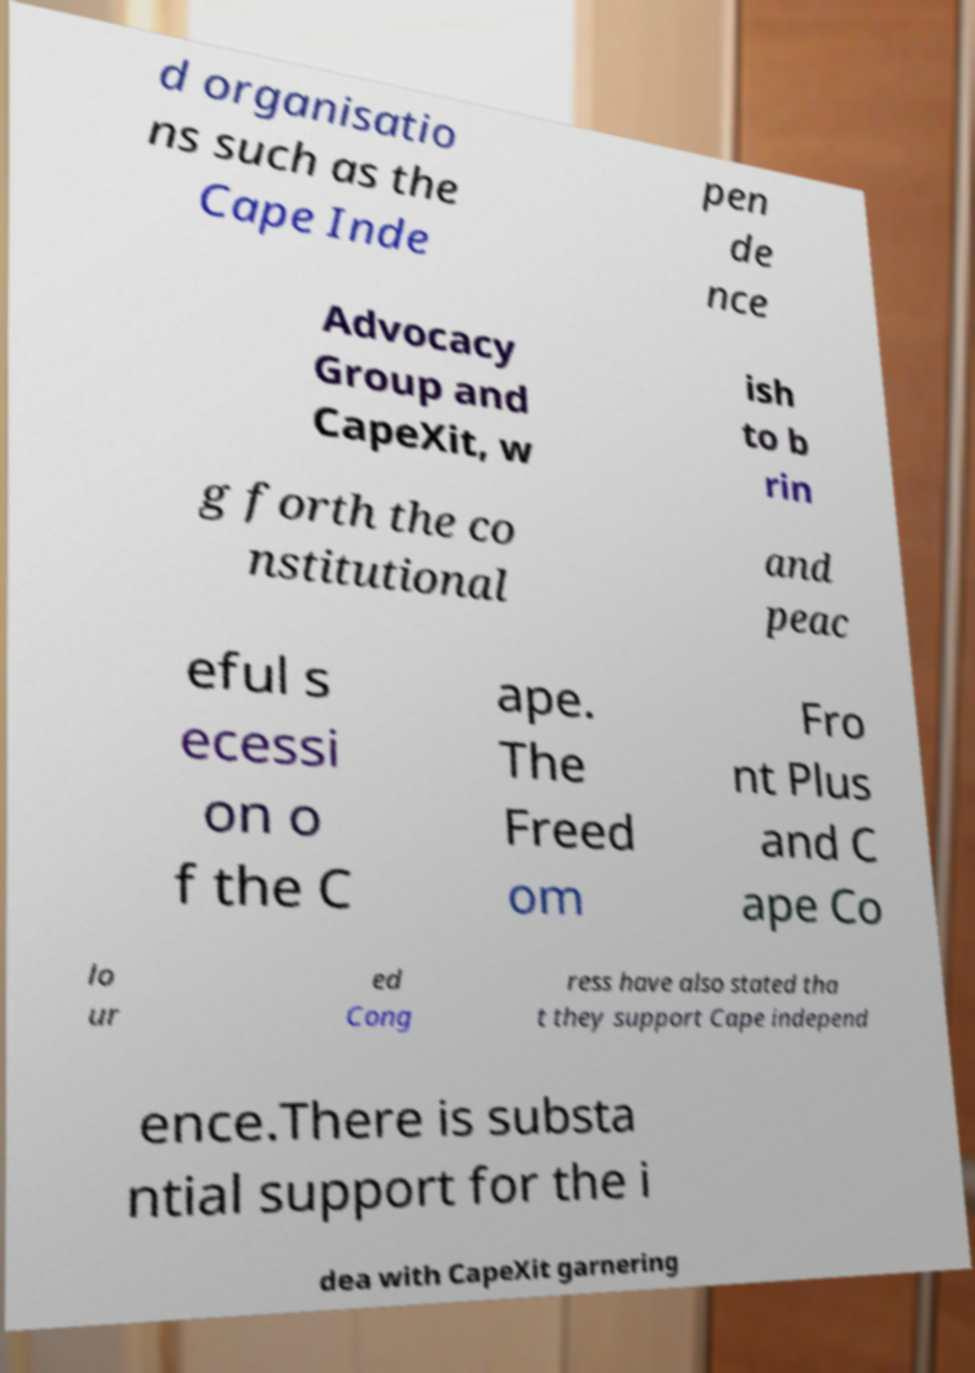For documentation purposes, I need the text within this image transcribed. Could you provide that? d organisatio ns such as the Cape Inde pen de nce Advocacy Group and CapeXit, w ish to b rin g forth the co nstitutional and peac eful s ecessi on o f the C ape. The Freed om Fro nt Plus and C ape Co lo ur ed Cong ress have also stated tha t they support Cape independ ence.There is substa ntial support for the i dea with CapeXit garnering 